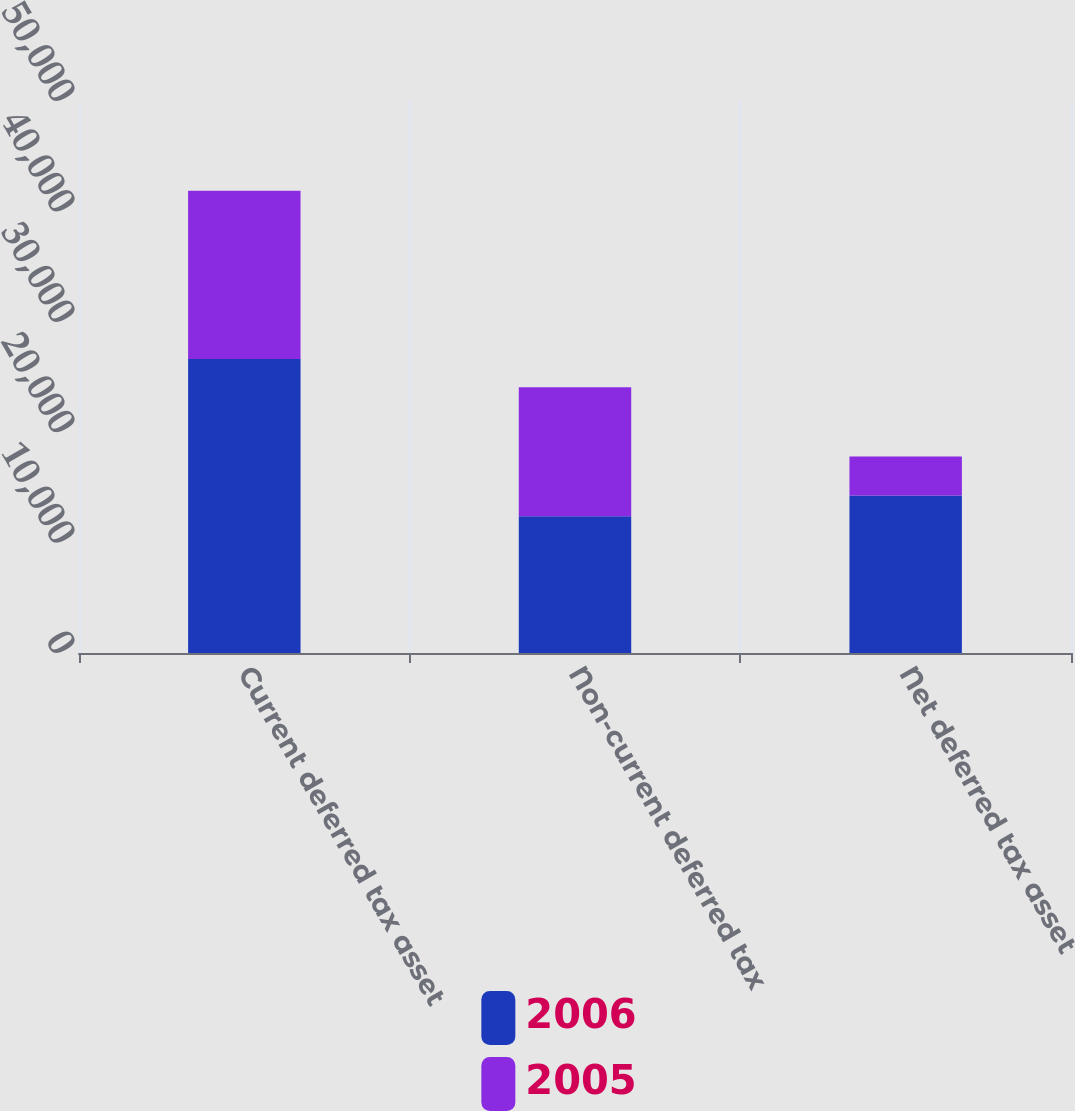Convert chart. <chart><loc_0><loc_0><loc_500><loc_500><stacked_bar_chart><ecel><fcel>Current deferred tax asset<fcel>Non-current deferred tax<fcel>Net deferred tax asset<nl><fcel>2006<fcel>26636<fcel>12377<fcel>14259<nl><fcel>2005<fcel>15230<fcel>11695<fcel>3535<nl></chart> 